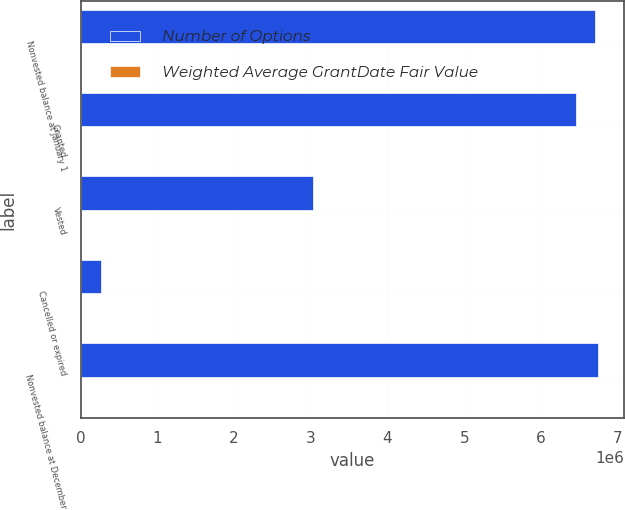<chart> <loc_0><loc_0><loc_500><loc_500><stacked_bar_chart><ecel><fcel>Nonvested balance at January 1<fcel>Granted<fcel>Vested<fcel>Cancelled or expired<fcel>Nonvested balance at December<nl><fcel>Number of Options<fcel>6.70755e+06<fcel>6.45152e+06<fcel>3.02378e+06<fcel>264300<fcel>6.74309e+06<nl><fcel>Weighted Average GrantDate Fair Value<fcel>4.41<fcel>5.96<fcel>3.28<fcel>4.06<fcel>7.52<nl></chart> 